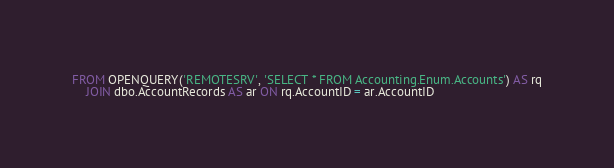<code> <loc_0><loc_0><loc_500><loc_500><_SQL_>FROM OPENQUERY('REMOTESRV', 'SELECT * FROM Accounting.Enum.Accounts') AS rq
    JOIN dbo.AccountRecords AS ar ON rq.AccountID = ar.AccountID</code> 